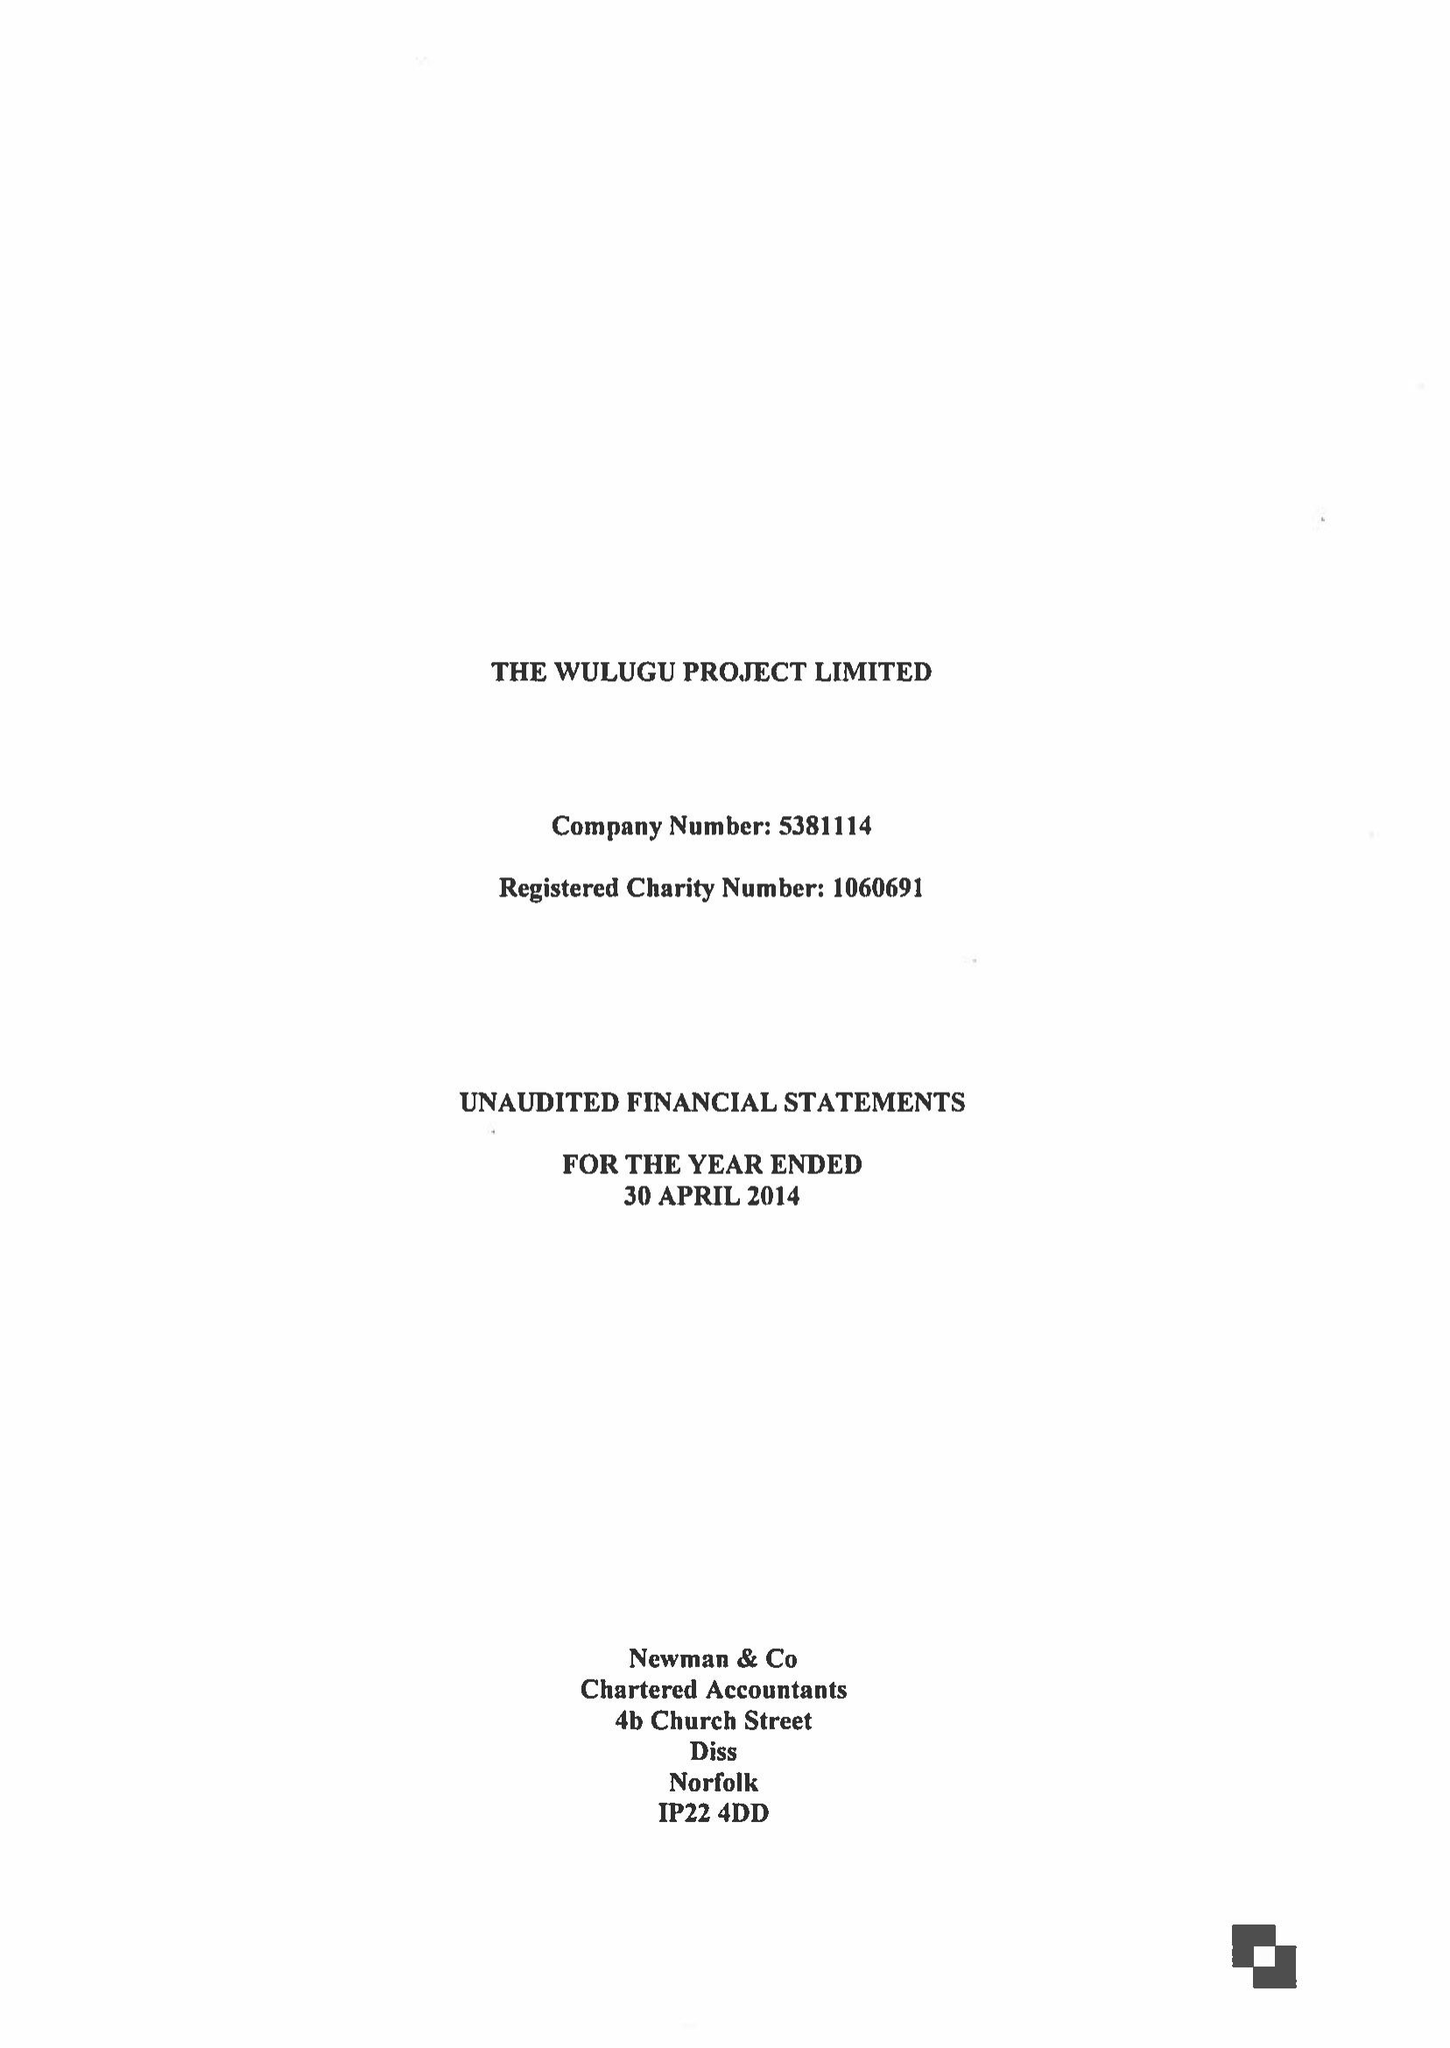What is the value for the charity_number?
Answer the question using a single word or phrase. 1060691 